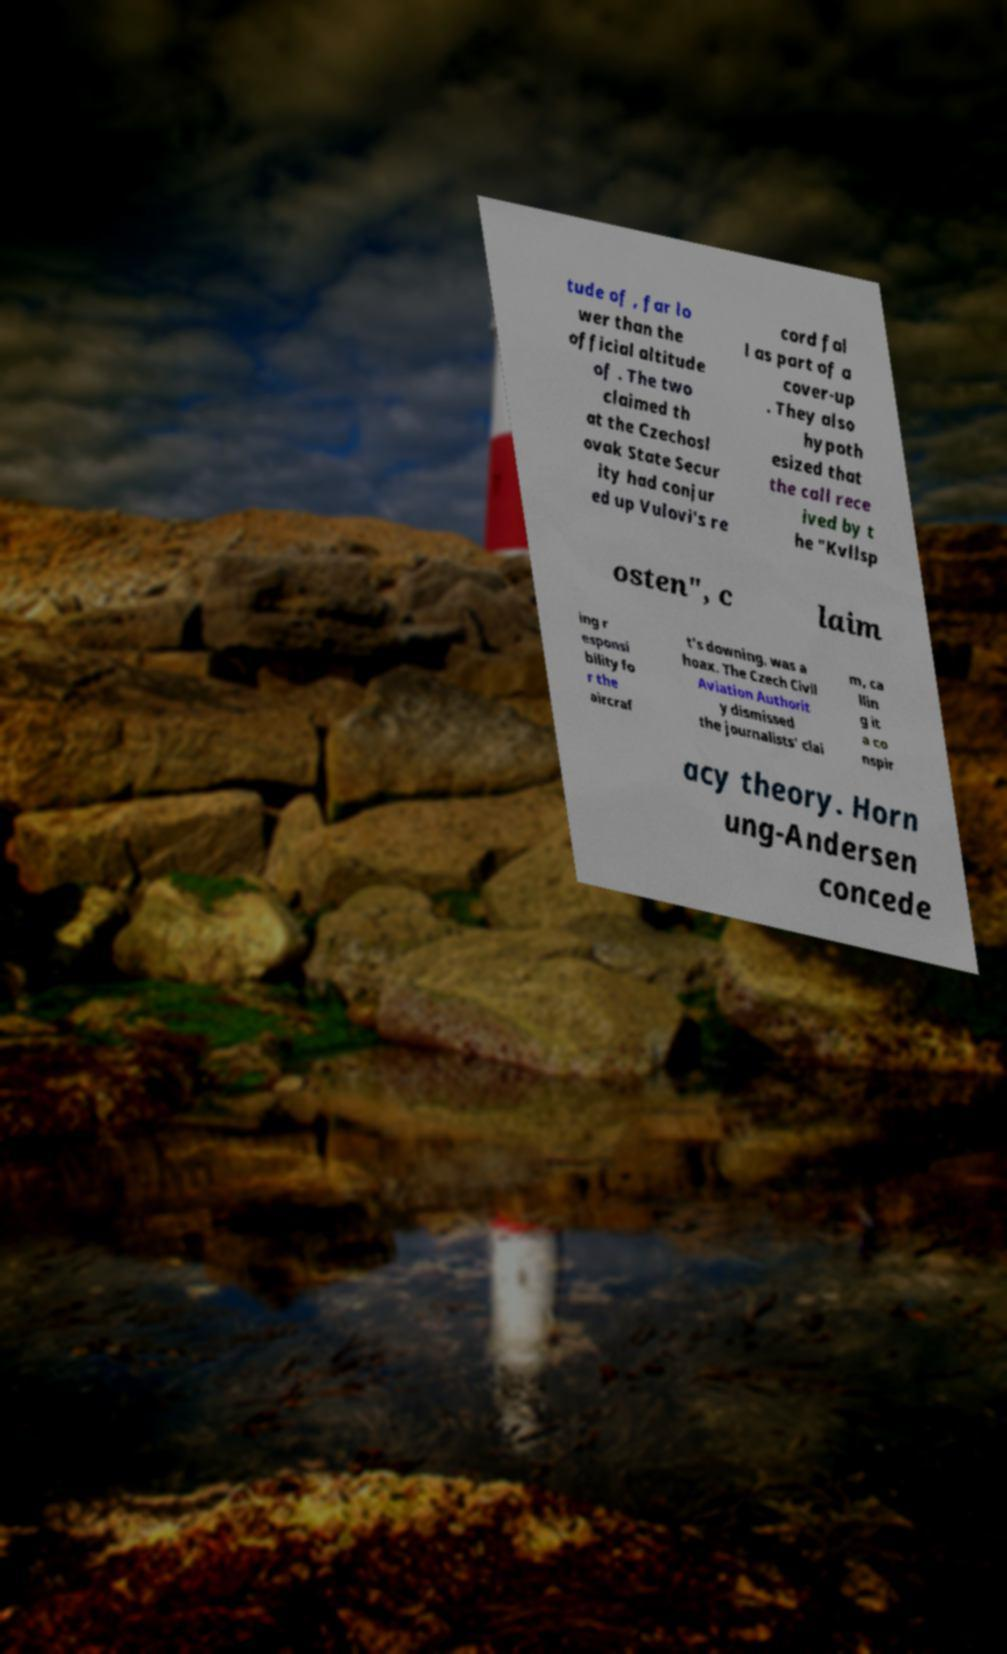I need the written content from this picture converted into text. Can you do that? tude of , far lo wer than the official altitude of . The two claimed th at the Czechosl ovak State Secur ity had conjur ed up Vulovi's re cord fal l as part of a cover-up . They also hypoth esized that the call rece ived by t he "Kvllsp osten", c laim ing r esponsi bility fo r the aircraf t's downing, was a hoax. The Czech Civil Aviation Authorit y dismissed the journalists' clai m, ca llin g it a co nspir acy theory. Horn ung-Andersen concede 